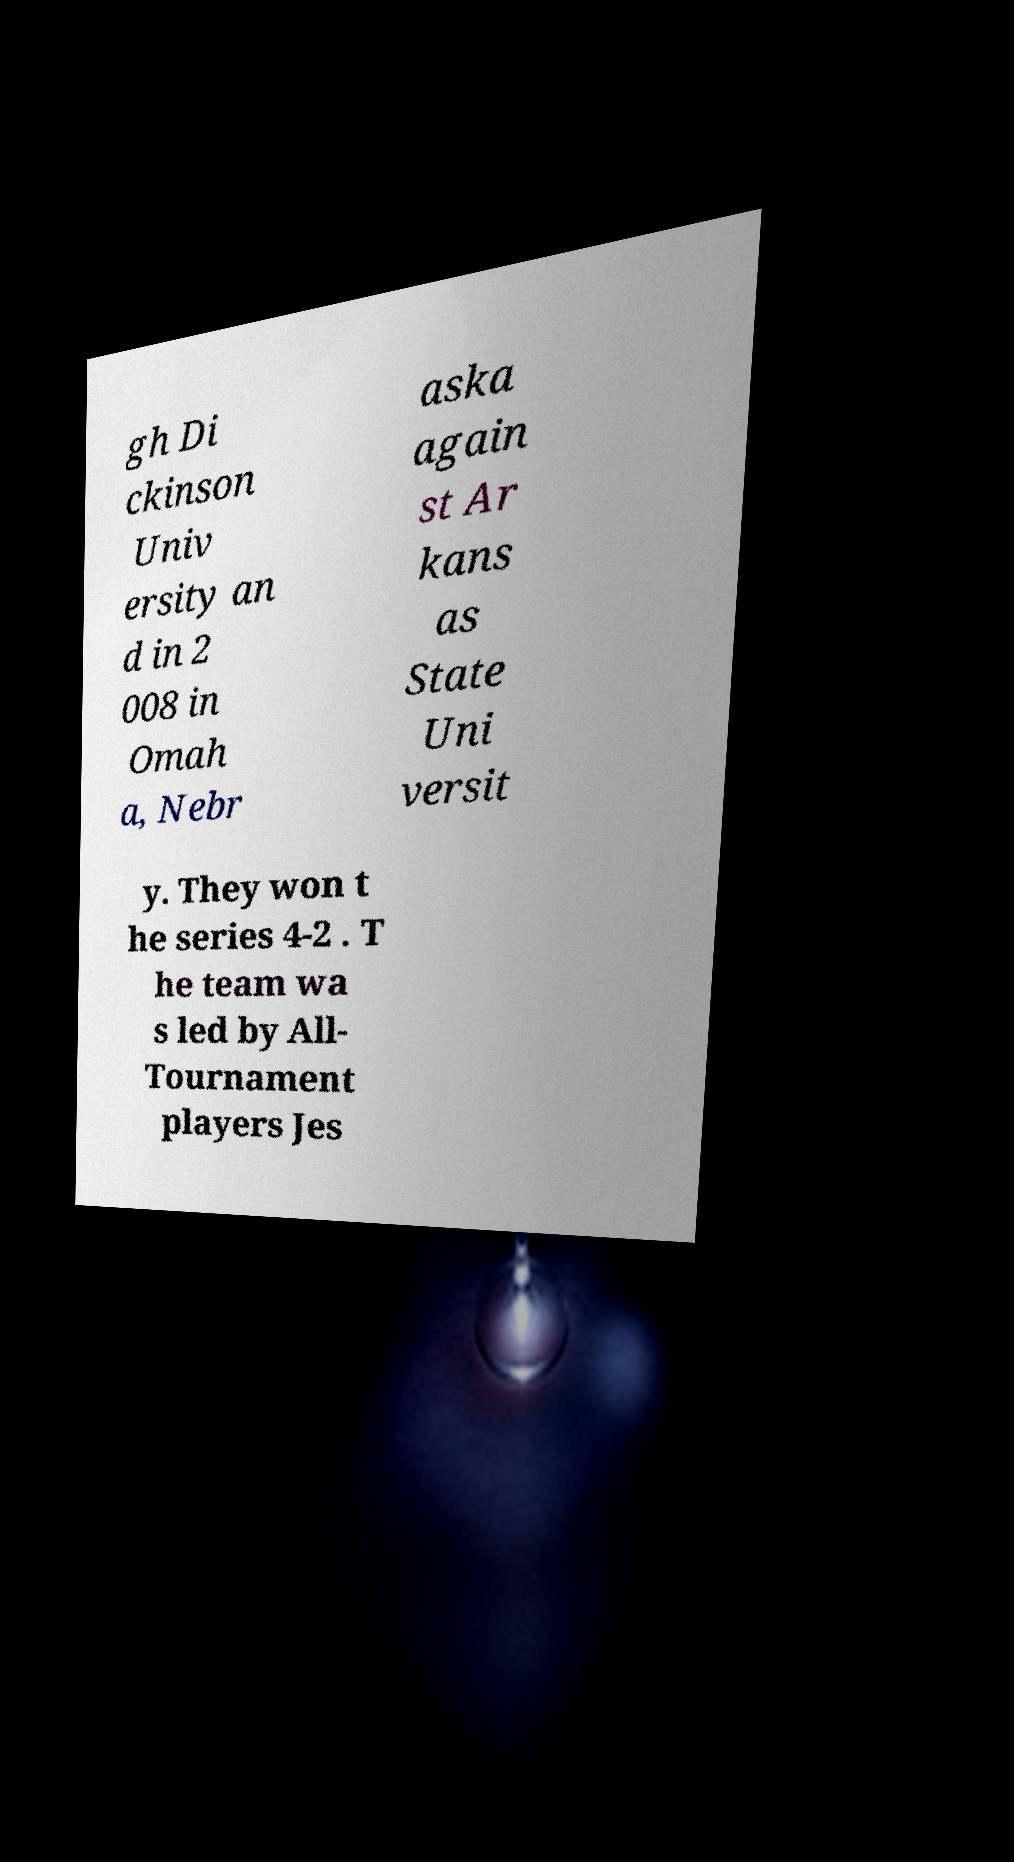For documentation purposes, I need the text within this image transcribed. Could you provide that? gh Di ckinson Univ ersity an d in 2 008 in Omah a, Nebr aska again st Ar kans as State Uni versit y. They won t he series 4-2 . T he team wa s led by All- Tournament players Jes 